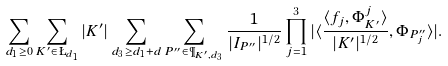Convert formula to latex. <formula><loc_0><loc_0><loc_500><loc_500>\sum _ { d _ { 1 } \geq 0 } \sum _ { K ^ { \prime } \in \L _ { d _ { 1 } } } | K ^ { \prime } | \sum _ { d _ { 3 } \geq d _ { 1 } + d } \sum _ { P ^ { \prime \prime } \in \P _ { K ^ { \prime } , d _ { 3 } } } \frac { 1 } { | I _ { P ^ { \prime \prime } } | ^ { 1 / 2 } } \prod _ { j = 1 } ^ { 3 } | \langle \frac { \langle f _ { j } , \Phi ^ { j } _ { K ^ { \prime } } \rangle } { | K ^ { \prime } | ^ { 1 / 2 } } , \Phi _ { P ^ { \prime \prime } _ { j } } \rangle | .</formula> 